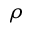Convert formula to latex. <formula><loc_0><loc_0><loc_500><loc_500>\rho</formula> 